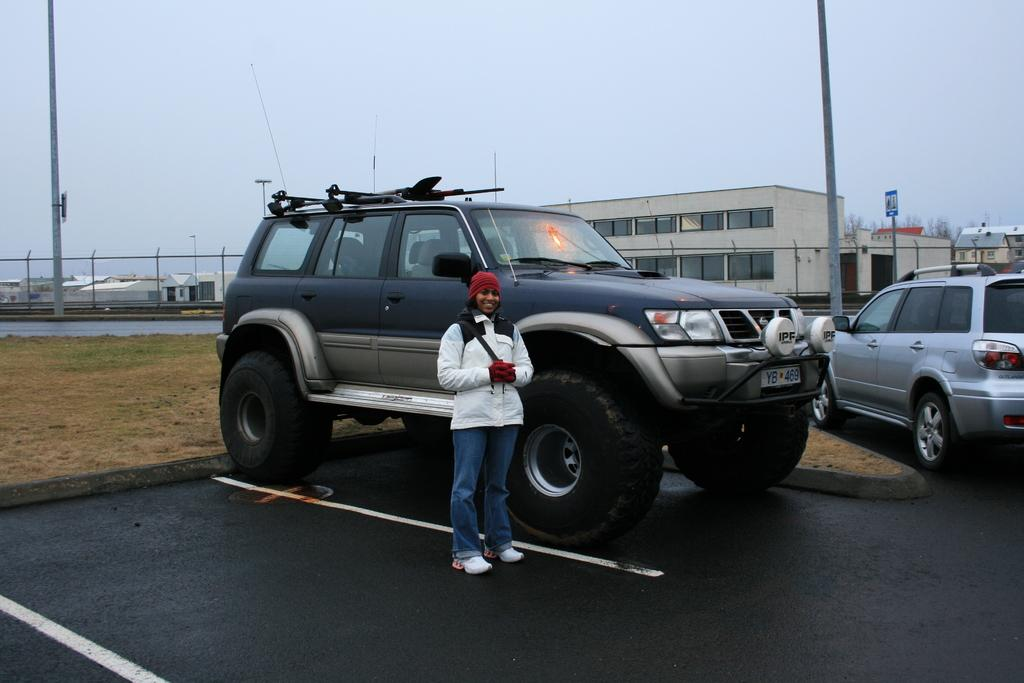How many cars are visible in the image? There are two cars in the image. What is the woman in the image doing? The woman is standing in front of the first car. What is located behind the first car? There is a ground behind the first car. What can be seen in the distance in the image? There are buildings and houses in the background of the image. What language is the snake speaking in the image? There is no snake present in the image, so it cannot be speaking any language. 